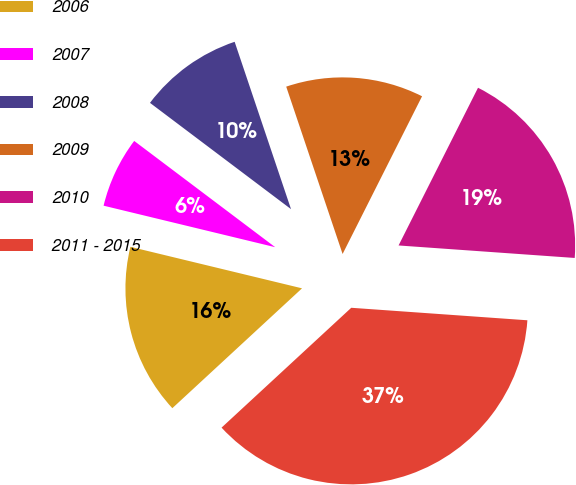<chart> <loc_0><loc_0><loc_500><loc_500><pie_chart><fcel>2006<fcel>2007<fcel>2008<fcel>2009<fcel>2010<fcel>2011 - 2015<nl><fcel>15.65%<fcel>6.5%<fcel>9.55%<fcel>12.6%<fcel>18.7%<fcel>37.0%<nl></chart> 